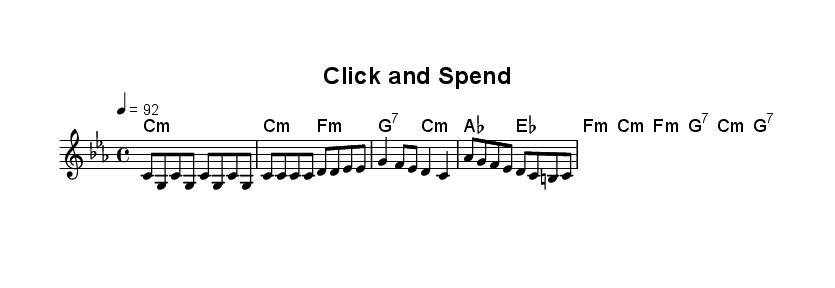What is the key signature of this music? The key signature is C minor, which contains three flats (B flat, E flat, and A flat). This is indicated at the beginning of the sheet music.
Answer: C minor What is the time signature of this piece? The time signature is 4/4, meaning there are four beats per measure and the quarter note gets one beat. This is displayed where the time signature is indicated at the beginning of the score.
Answer: 4/4 What is the tempo marking for this music? The tempo marking is 92 beats per minute, as specified in the score where it shows "4 = 92". This indicates the speed at which the piece should be played.
Answer: 92 How many measures are there in the verse? The verse consists of four measures, as counted in the melody section where each group of notes is divided by vertical bar lines.
Answer: 4 What is the primary theme of the lyrics? The primary theme of the lyrics critiques excessive consumerism and online shopping habits, as seen in phrases like "scrolling through the web" and "click and spend". This is evident from the content of the provided lyrics.
Answer: Consumerism How many chords are used in the chorus? The chorus uses two chords, which are indicated in the harmonies section as two distinct musical symbols for as and es. Each chord is played for two beats.
Answer: 2 What is the overall mood conveyed by the music? The overall mood conveyed by the music can be described as satirical, as it critiques excessive spending and consumer behavior through its lyrics and rhythmic structure. This can be inferred from the repeated themes in the verses and chorus.
Answer: Satirical 